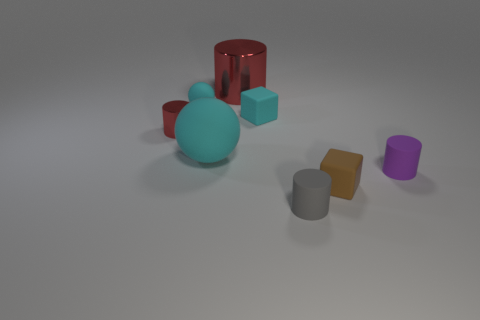The small cyan matte thing that is on the right side of the cyan sphere that is behind the small red metal cylinder is what shape?
Provide a succinct answer. Cube. What number of objects are purple objects or small rubber cubes that are right of the gray matte object?
Keep it short and to the point. 2. The tiny matte cube left of the cylinder that is in front of the small matte cylinder right of the tiny brown matte thing is what color?
Provide a short and direct response. Cyan. There is a big object that is the same shape as the tiny gray thing; what is its material?
Your answer should be compact. Metal. The large metal cylinder is what color?
Make the answer very short. Red. Does the small ball have the same color as the small metallic object?
Your answer should be compact. No. What number of shiny things are tiny gray things or cyan spheres?
Provide a short and direct response. 0. There is a shiny cylinder behind the cyan block on the right side of the large cyan matte sphere; are there any big red shiny objects that are in front of it?
Your answer should be compact. No. What is the size of the thing that is made of the same material as the big red cylinder?
Provide a short and direct response. Small. There is a tiny purple rubber thing; are there any tiny gray rubber objects behind it?
Give a very brief answer. No. 